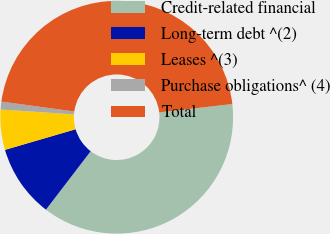<chart> <loc_0><loc_0><loc_500><loc_500><pie_chart><fcel>Credit-related financial<fcel>Long-term debt ^(2)<fcel>Leases ^(3)<fcel>Purchase obligations^ (4)<fcel>Total<nl><fcel>37.21%<fcel>10.08%<fcel>5.58%<fcel>1.09%<fcel>46.04%<nl></chart> 